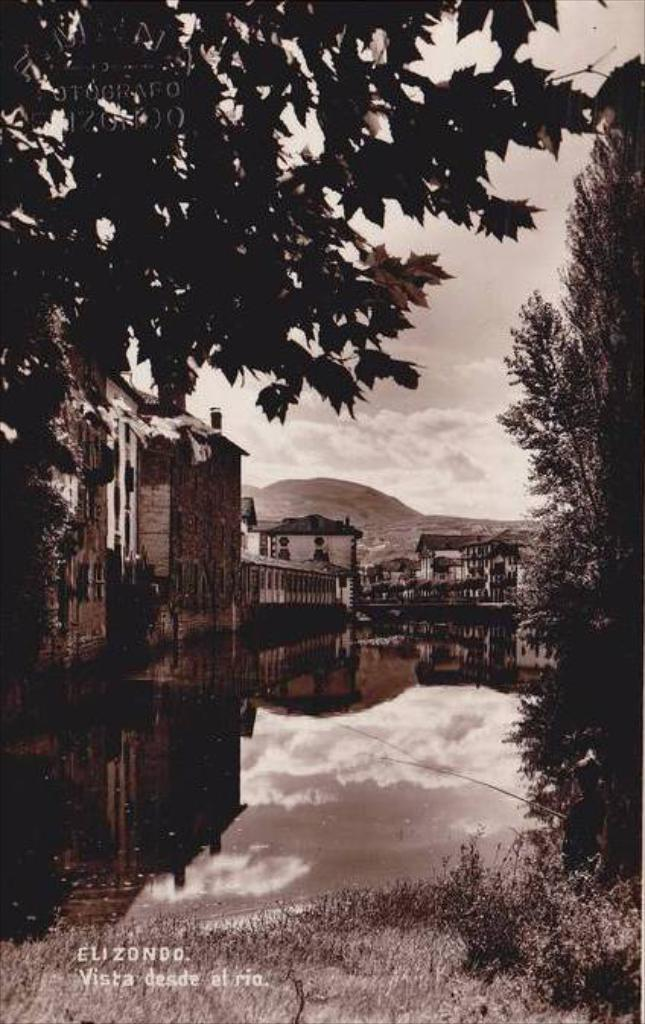What type of structures can be seen in the image? There are buildings in the image. What natural element is visible in the image? There is water visible in the image. What type of vegetation is present in the image? There are trees in the image. How would you describe the weather in the image? The sky is cloudy in the image. What can be found at the bottom of the image? There is text at the bottom of the image. How many cattle can be seen grazing near the water in the image? There are no cattle present in the image. What type of gardening tool is being used to trim the trees in the image? There is no gardening tool or tree trimming activity depicted in the image. 